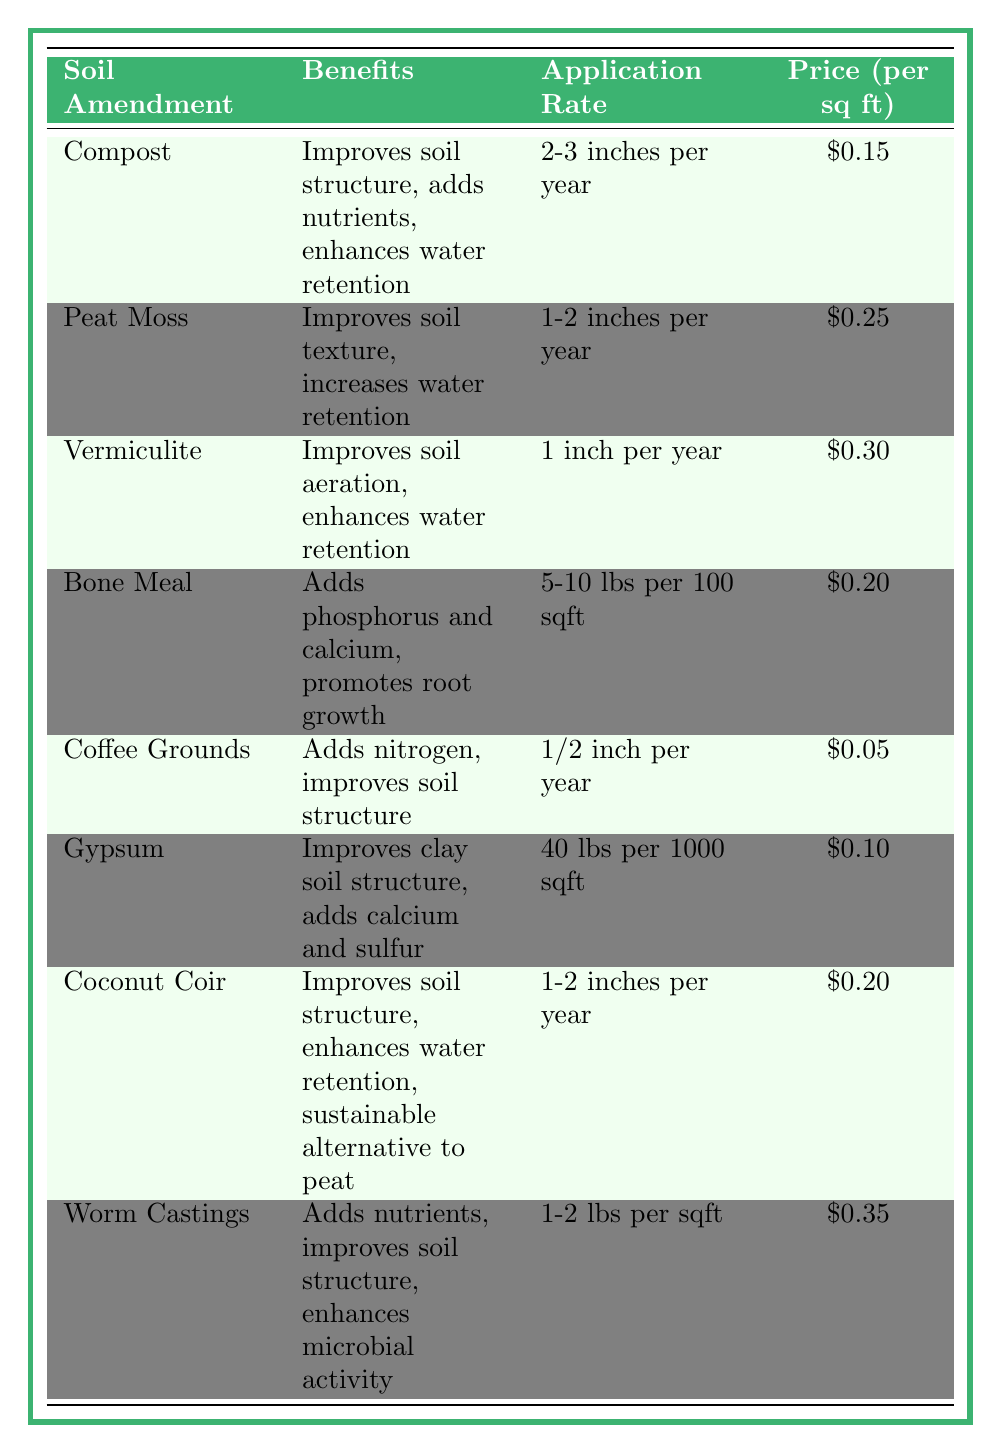What is the price per square foot for Compost? The table indicates that Compost has a price of $0.15 per square foot.
Answer: $0.15 Which soil amendment has the highest price per square foot? By comparing the prices of all soil amendments, Worm Castings are the most expensive at $0.35 per square foot.
Answer: $0.35 How much application rate is suggested for Peat Moss? The table states that Peat Moss should be applied at a rate of 1-2 inches per year.
Answer: 1-2 inches per year What benefits does Coconut Coir provide? Coconut Coir improves soil structure, enhances water retention, and serves as a sustainable alternative to peat, as noted in the table.
Answer: Improves soil structure, enhances water retention, sustainable alternative to peat Is Gypsum beneficial for clay soil? Yes, the table specifies that Gypsum improves clay soil structure and adds calcium and sulfur.
Answer: Yes What is the total price per square foot for applying both Coffee Grounds and Gypsum? The price for Coffee Grounds is $0.05 and for Gypsum is $0.10. Adding these gives $0.05 + $0.10 = $0.15 for both.
Answer: $0.15 If I apply 100 square feet of Bone Meal, how much will it cost? Bone Meal costs $0.20 per square foot, so for 100 square feet the cost would be 100 * $0.20 = $20.
Answer: $20 Which soil amendment improves water retention but has a lower price than Vermiculite? Compost and Coconut Coir improve water retention and both have a price per square foot lower than Vermiculite's $0.30 (Compost is $0.15 and Coconut Coir is $0.20).
Answer: Compost and Coconut Coir What is the average price per square foot of all soil amendments listed? Adding all the prices ($0.15 + $0.25 + $0.30 + $0.20 + $0.05 + $0.10 + $0.20 + $0.35) gives $1.40, divided by 8 amendments results in an average of $1.40 / 8 = $0.175.
Answer: $0.175 Which soil amendment requires the least amount of application? The application rate for Coffee Grounds is the least at 1/2 inch per year.
Answer: 1/2 inch per year What are the benefits of using Worm Castings? Worm Castings add nutrients, improve soil structure, and enhance microbial activity according to the table.
Answer: Adds nutrients, improves soil structure, enhances microbial activity 